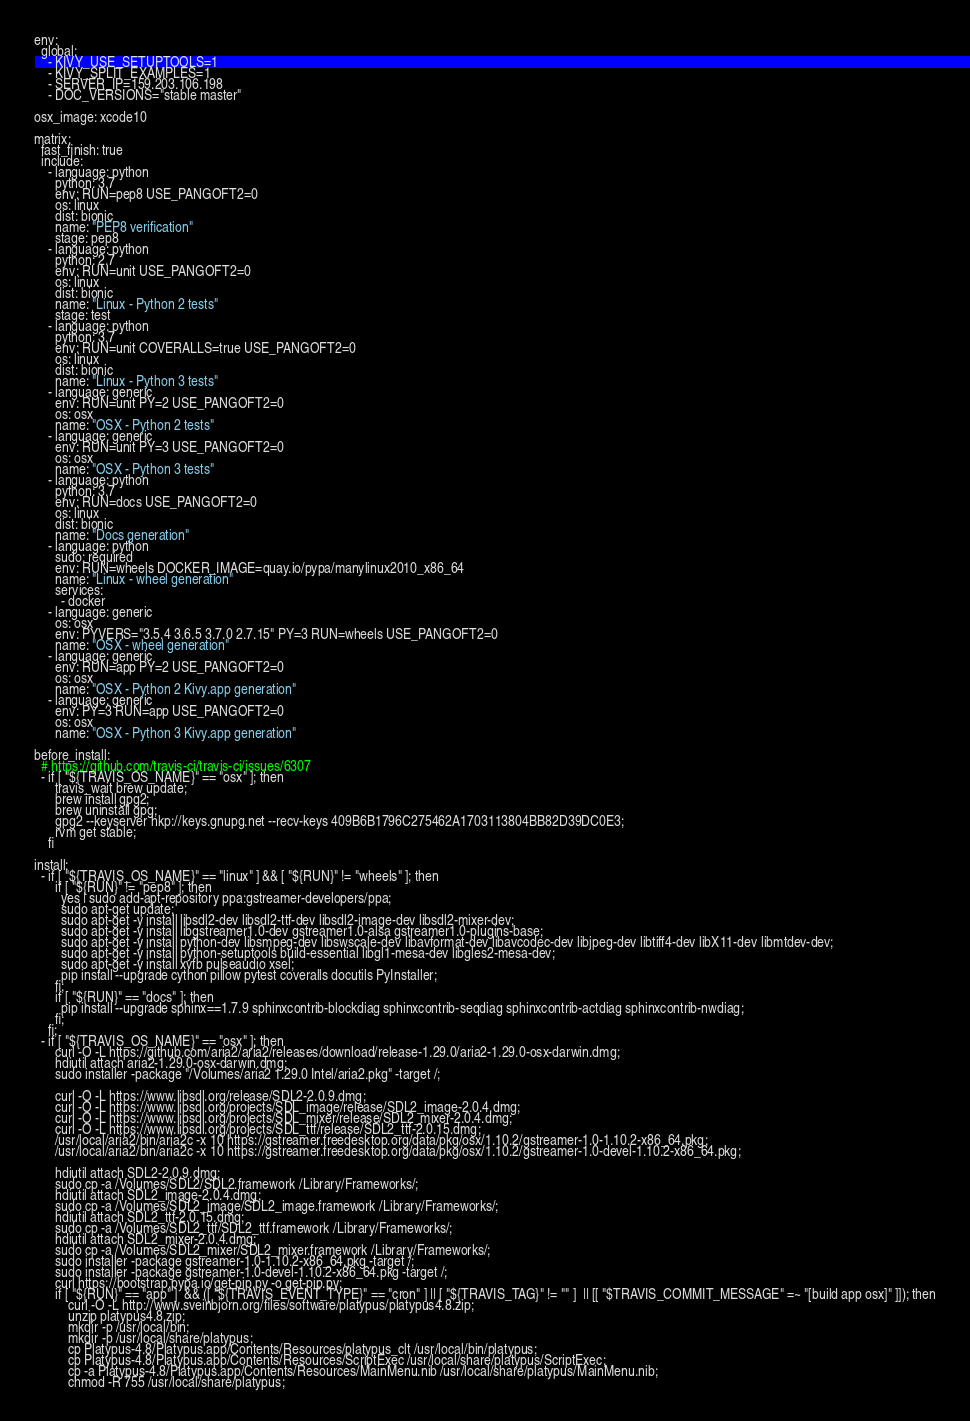Convert code to text. <code><loc_0><loc_0><loc_500><loc_500><_YAML_>env:
  global:
    - KIVY_USE_SETUPTOOLS=1
    - KIVY_SPLIT_EXAMPLES=1
    - SERVER_IP=159.203.106.198
    - DOC_VERSIONS="stable master"

osx_image: xcode10

matrix:
  fast_finish: true
  include:
    - language: python
      python: 3.7
      env: RUN=pep8 USE_PANGOFT2=0
      os: linux
      dist: bionic
      name: "PEP8 verification"
      stage: pep8
    - language: python
      python: 2.7
      env: RUN=unit USE_PANGOFT2=0
      os: linux
      dist: bionic
      name: "Linux - Python 2 tests"
      stage: test
    - language: python
      python: 3.7
      env: RUN=unit COVERALLS=true USE_PANGOFT2=0
      os: linux
      dist: bionic
      name: "Linux - Python 3 tests"
    - language: generic
      env: RUN=unit PY=2 USE_PANGOFT2=0
      os: osx
      name: "OSX - Python 2 tests"
    - language: generic
      env: RUN=unit PY=3 USE_PANGOFT2=0
      os: osx
      name: "OSX - Python 3 tests"
    - language: python
      python: 3.7
      env: RUN=docs USE_PANGOFT2=0
      os: linux
      dist: bionic
      name: "Docs generation"
    - language: python
      sudo: required
      env: RUN=wheels DOCKER_IMAGE=quay.io/pypa/manylinux2010_x86_64
      name: "Linux - wheel generation"
      services:
        - docker
    - language: generic
      os: osx
      env: PYVERS="3.5.4 3.6.5 3.7.0 2.7.15" PY=3 RUN=wheels USE_PANGOFT2=0
      name: "OSX - wheel generation"
    - language: generic
      env: RUN=app PY=2 USE_PANGOFT2=0
      os: osx
      name: "OSX - Python 2 Kivy.app generation"
    - language: generic
      env: PY=3 RUN=app USE_PANGOFT2=0
      os: osx
      name: "OSX - Python 3 Kivy.app generation"

before_install:
  # https://github.com/travis-ci/travis-ci/issues/6307
  - if [ "${TRAVIS_OS_NAME}" == "osx" ]; then
      travis_wait brew update;
      brew install gpg2;
      brew uninstall gpg;
      gpg2 --keyserver hkp://keys.gnupg.net --recv-keys 409B6B1796C275462A1703113804BB82D39DC0E3;
      rvm get stable;
    fi

install:
  - if [ "${TRAVIS_OS_NAME}" == "linux" ] && [ "${RUN}" != "wheels" ]; then
      if [ "${RUN}" != "pep8" ]; then
        yes | sudo add-apt-repository ppa:gstreamer-developers/ppa;
        sudo apt-get update;
        sudo apt-get -y install libsdl2-dev libsdl2-ttf-dev libsdl2-image-dev libsdl2-mixer-dev;
        sudo apt-get -y install libgstreamer1.0-dev gstreamer1.0-alsa gstreamer1.0-plugins-base;
        sudo apt-get -y install python-dev libsmpeg-dev libswscale-dev libavformat-dev libavcodec-dev libjpeg-dev libtiff4-dev libX11-dev libmtdev-dev;
        sudo apt-get -y install python-setuptools build-essential libgl1-mesa-dev libgles2-mesa-dev;
        sudo apt-get -y install xvfb pulseaudio xsel;
        pip install --upgrade cython pillow pytest coveralls docutils PyInstaller;
      fi;
      if [ "${RUN}" == "docs" ]; then
        pip install --upgrade sphinx==1.7.9 sphinxcontrib-blockdiag sphinxcontrib-seqdiag sphinxcontrib-actdiag sphinxcontrib-nwdiag;
      fi;
    fi;
  - if [ "${TRAVIS_OS_NAME}" == "osx" ]; then
      curl -O -L https://github.com/aria2/aria2/releases/download/release-1.29.0/aria2-1.29.0-osx-darwin.dmg;
      hdiutil attach aria2-1.29.0-osx-darwin.dmg;
      sudo installer -package "/Volumes/aria2 1.29.0 Intel/aria2.pkg" -target /;

      curl -O -L https://www.libsdl.org/release/SDL2-2.0.9.dmg;
      curl -O -L https://www.libsdl.org/projects/SDL_image/release/SDL2_image-2.0.4.dmg;
      curl -O -L https://www.libsdl.org/projects/SDL_mixer/release/SDL2_mixer-2.0.4.dmg;
      curl -O -L https://www.libsdl.org/projects/SDL_ttf/release/SDL2_ttf-2.0.15.dmg;
      /usr/local/aria2/bin/aria2c -x 10 https://gstreamer.freedesktop.org/data/pkg/osx/1.10.2/gstreamer-1.0-1.10.2-x86_64.pkg;
      /usr/local/aria2/bin/aria2c -x 10 https://gstreamer.freedesktop.org/data/pkg/osx/1.10.2/gstreamer-1.0-devel-1.10.2-x86_64.pkg;

      hdiutil attach SDL2-2.0.9.dmg;
      sudo cp -a /Volumes/SDL2/SDL2.framework /Library/Frameworks/;
      hdiutil attach SDL2_image-2.0.4.dmg;
      sudo cp -a /Volumes/SDL2_image/SDL2_image.framework /Library/Frameworks/;
      hdiutil attach SDL2_ttf-2.0.15.dmg;
      sudo cp -a /Volumes/SDL2_ttf/SDL2_ttf.framework /Library/Frameworks/;
      hdiutil attach SDL2_mixer-2.0.4.dmg;
      sudo cp -a /Volumes/SDL2_mixer/SDL2_mixer.framework /Library/Frameworks/;
      sudo installer -package gstreamer-1.0-1.10.2-x86_64.pkg -target /;
      sudo installer -package gstreamer-1.0-devel-1.10.2-x86_64.pkg -target /;
      curl https://bootstrap.pypa.io/get-pip.py -o get-pip.py;
      if [ "${RUN}" == "app" ]  && ([ "${TRAVIS_EVENT_TYPE}" == "cron" ] || [ "${TRAVIS_TAG}" != "" ]  || [[ "$TRAVIS_COMMIT_MESSAGE" =~ "[build app osx]" ]]); then
          curl -O -L http://www.sveinbjorn.org/files/software/platypus/platypus4.8.zip;
          unzip platypus4.8.zip;
          mkdir -p /usr/local/bin;
          mkdir -p /usr/local/share/platypus;
          cp Platypus-4.8/Platypus.app/Contents/Resources/platypus_clt /usr/local/bin/platypus;
          cp Platypus-4.8/Platypus.app/Contents/Resources/ScriptExec /usr/local/share/platypus/ScriptExec;
          cp -a Platypus-4.8/Platypus.app/Contents/Resources/MainMenu.nib /usr/local/share/platypus/MainMenu.nib;
          chmod -R 755 /usr/local/share/platypus;</code> 